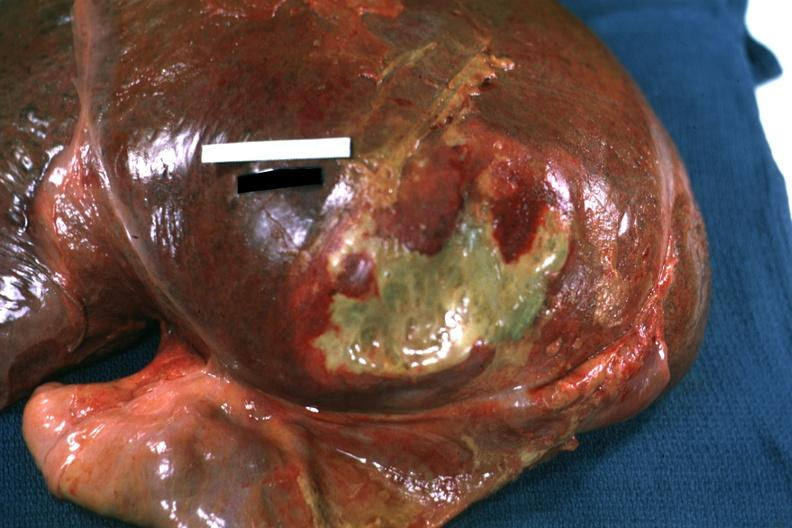what is present?
Answer the question using a single word or phrase. Liver 